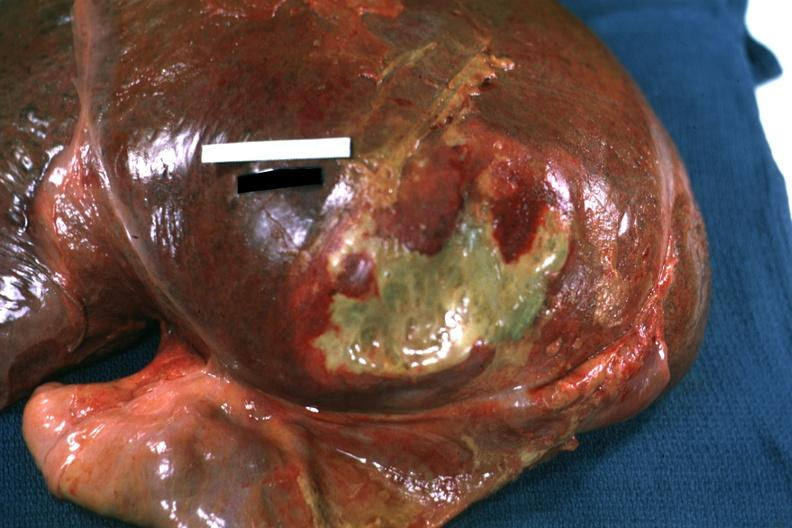what is present?
Answer the question using a single word or phrase. Liver 